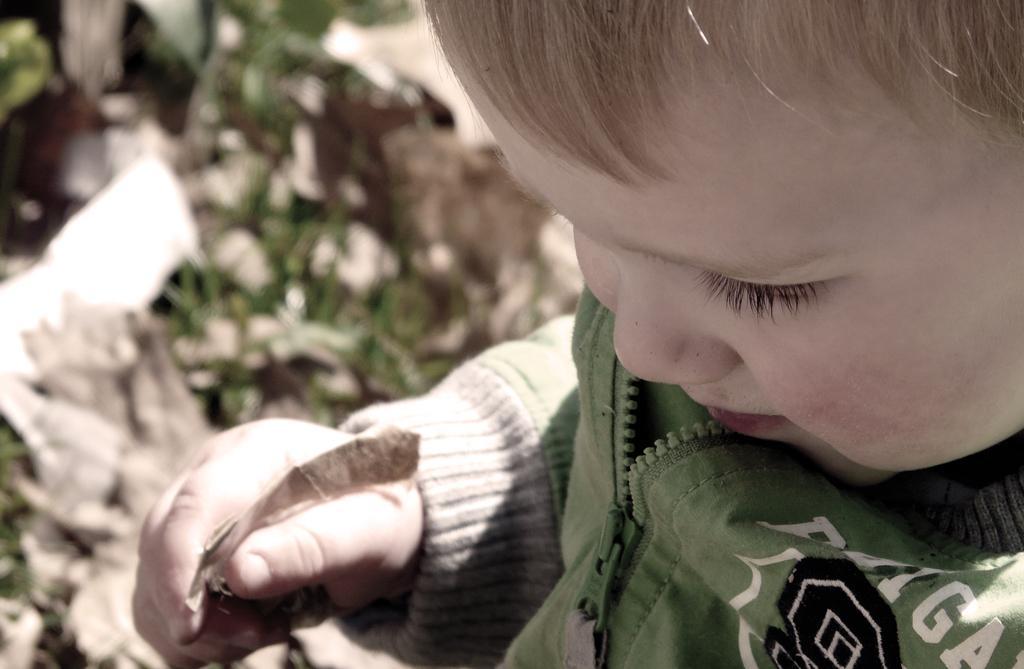Describe this image in one or two sentences. In this image in the foreground there is one boy who is holding something, and in the background there are some plants. 